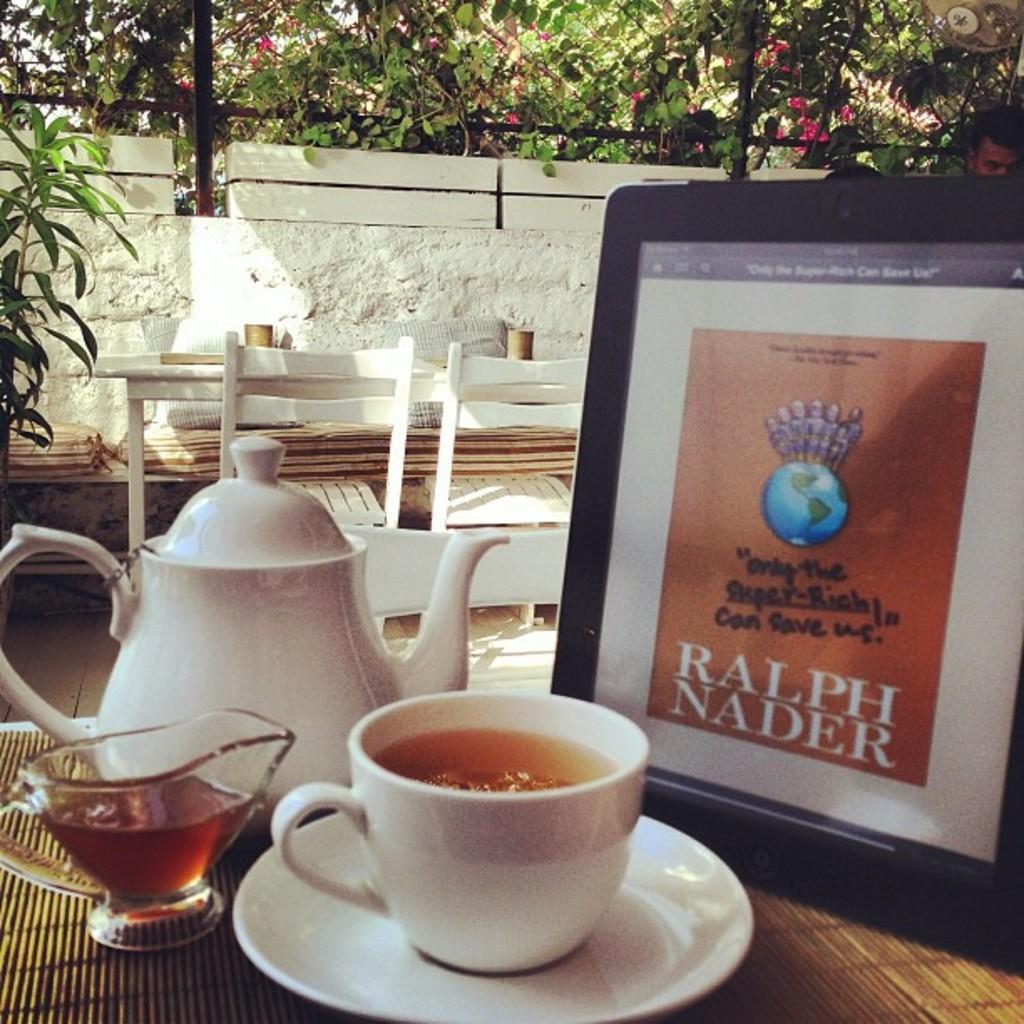Can you describe this image briefly? This picture is taken outside. In the left bottom there is a table. On the table there is a kettle, cup, saucer and a frame. In the center there is an another table and chairs, towards the left there is a plant. In the background there is a wall and some plants. Towards the right there is a person. 